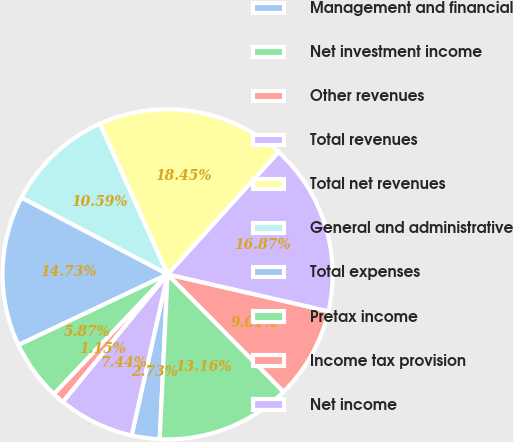<chart> <loc_0><loc_0><loc_500><loc_500><pie_chart><fcel>Management and financial<fcel>Net investment income<fcel>Other revenues<fcel>Total revenues<fcel>Total net revenues<fcel>General and administrative<fcel>Total expenses<fcel>Pretax income<fcel>Income tax provision<fcel>Net income<nl><fcel>2.73%<fcel>13.16%<fcel>9.01%<fcel>16.87%<fcel>18.45%<fcel>10.59%<fcel>14.73%<fcel>5.87%<fcel>1.15%<fcel>7.44%<nl></chart> 